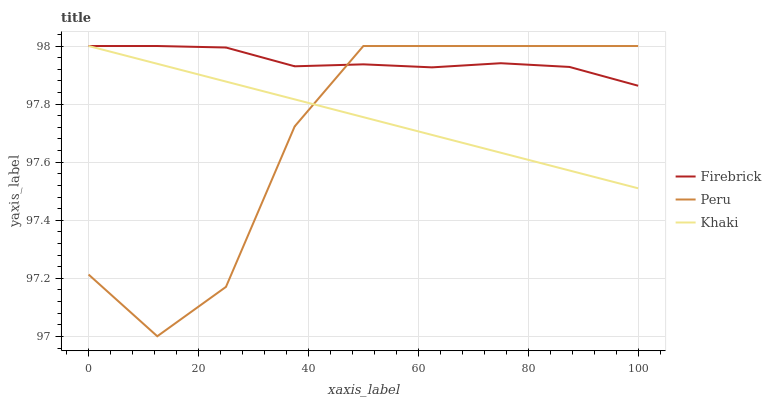Does Peru have the minimum area under the curve?
Answer yes or no. Yes. Does Firebrick have the maximum area under the curve?
Answer yes or no. Yes. Does Khaki have the minimum area under the curve?
Answer yes or no. No. Does Khaki have the maximum area under the curve?
Answer yes or no. No. Is Khaki the smoothest?
Answer yes or no. Yes. Is Peru the roughest?
Answer yes or no. Yes. Is Peru the smoothest?
Answer yes or no. No. Is Khaki the roughest?
Answer yes or no. No. Does Khaki have the lowest value?
Answer yes or no. No. Does Peru have the highest value?
Answer yes or no. Yes. Does Khaki intersect Firebrick?
Answer yes or no. Yes. Is Khaki less than Firebrick?
Answer yes or no. No. Is Khaki greater than Firebrick?
Answer yes or no. No. 